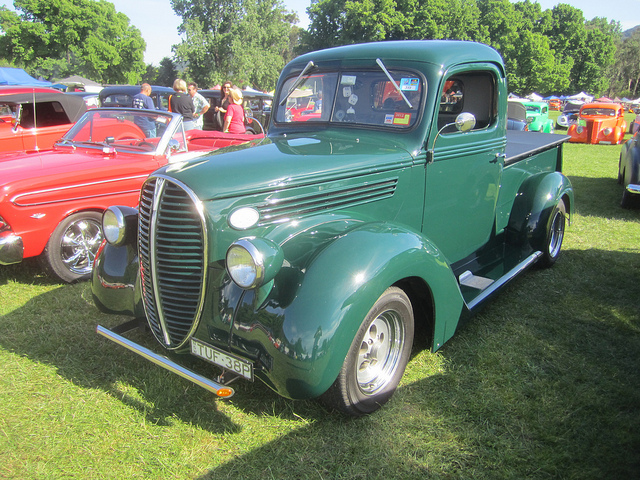Read and extract the text from this image. TUF 38P 